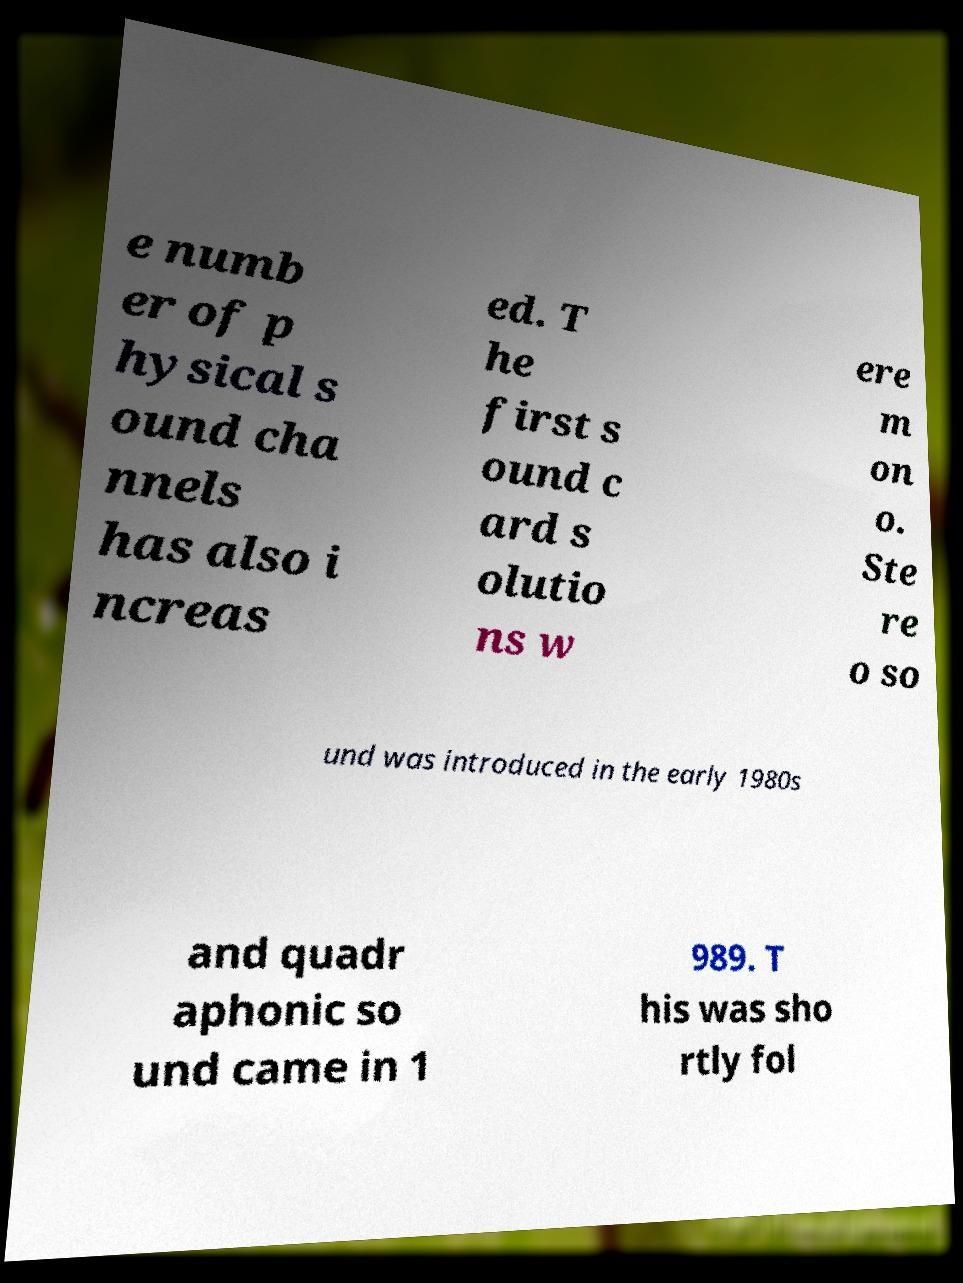Can you read and provide the text displayed in the image?This photo seems to have some interesting text. Can you extract and type it out for me? e numb er of p hysical s ound cha nnels has also i ncreas ed. T he first s ound c ard s olutio ns w ere m on o. Ste re o so und was introduced in the early 1980s and quadr aphonic so und came in 1 989. T his was sho rtly fol 